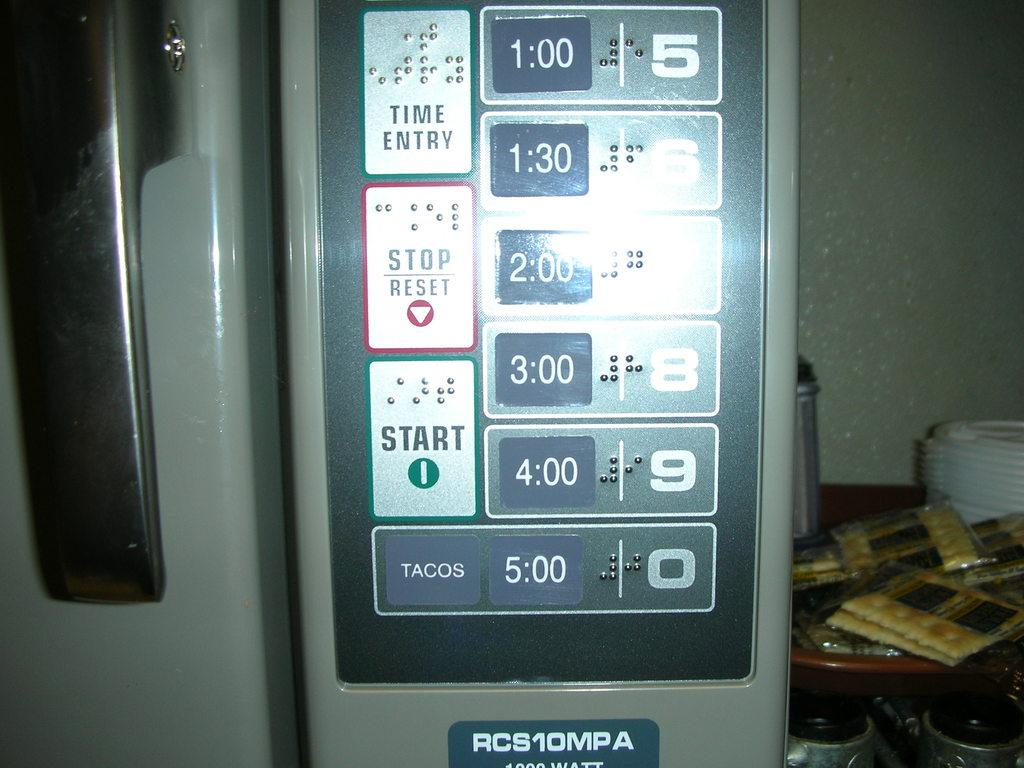Provide a one-sentence caption for the provided image. a digital display close up with buttons reading START and RESET. 